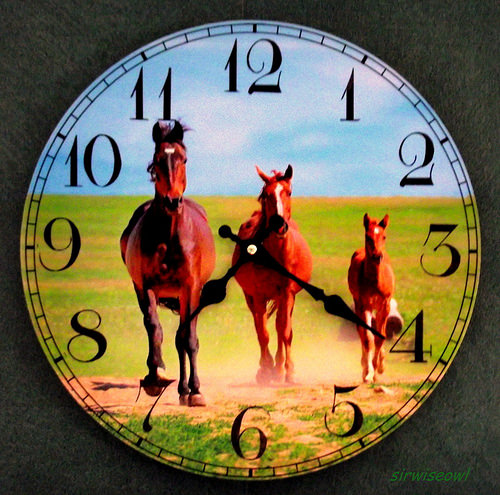<image>
Is there a horse on the clock? Yes. Looking at the image, I can see the horse is positioned on top of the clock, with the clock providing support. 